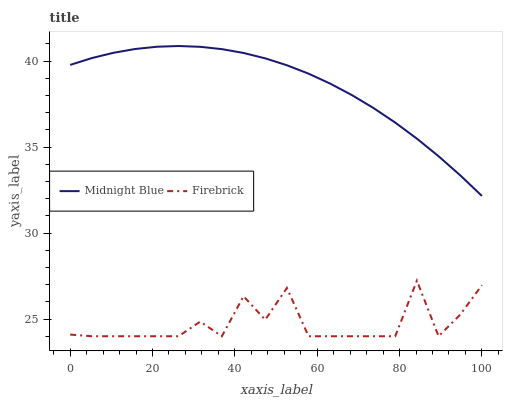Does Firebrick have the minimum area under the curve?
Answer yes or no. Yes. Does Midnight Blue have the maximum area under the curve?
Answer yes or no. Yes. Does Midnight Blue have the minimum area under the curve?
Answer yes or no. No. Is Midnight Blue the smoothest?
Answer yes or no. Yes. Is Firebrick the roughest?
Answer yes or no. Yes. Is Midnight Blue the roughest?
Answer yes or no. No. Does Firebrick have the lowest value?
Answer yes or no. Yes. Does Midnight Blue have the lowest value?
Answer yes or no. No. Does Midnight Blue have the highest value?
Answer yes or no. Yes. Is Firebrick less than Midnight Blue?
Answer yes or no. Yes. Is Midnight Blue greater than Firebrick?
Answer yes or no. Yes. Does Firebrick intersect Midnight Blue?
Answer yes or no. No. 